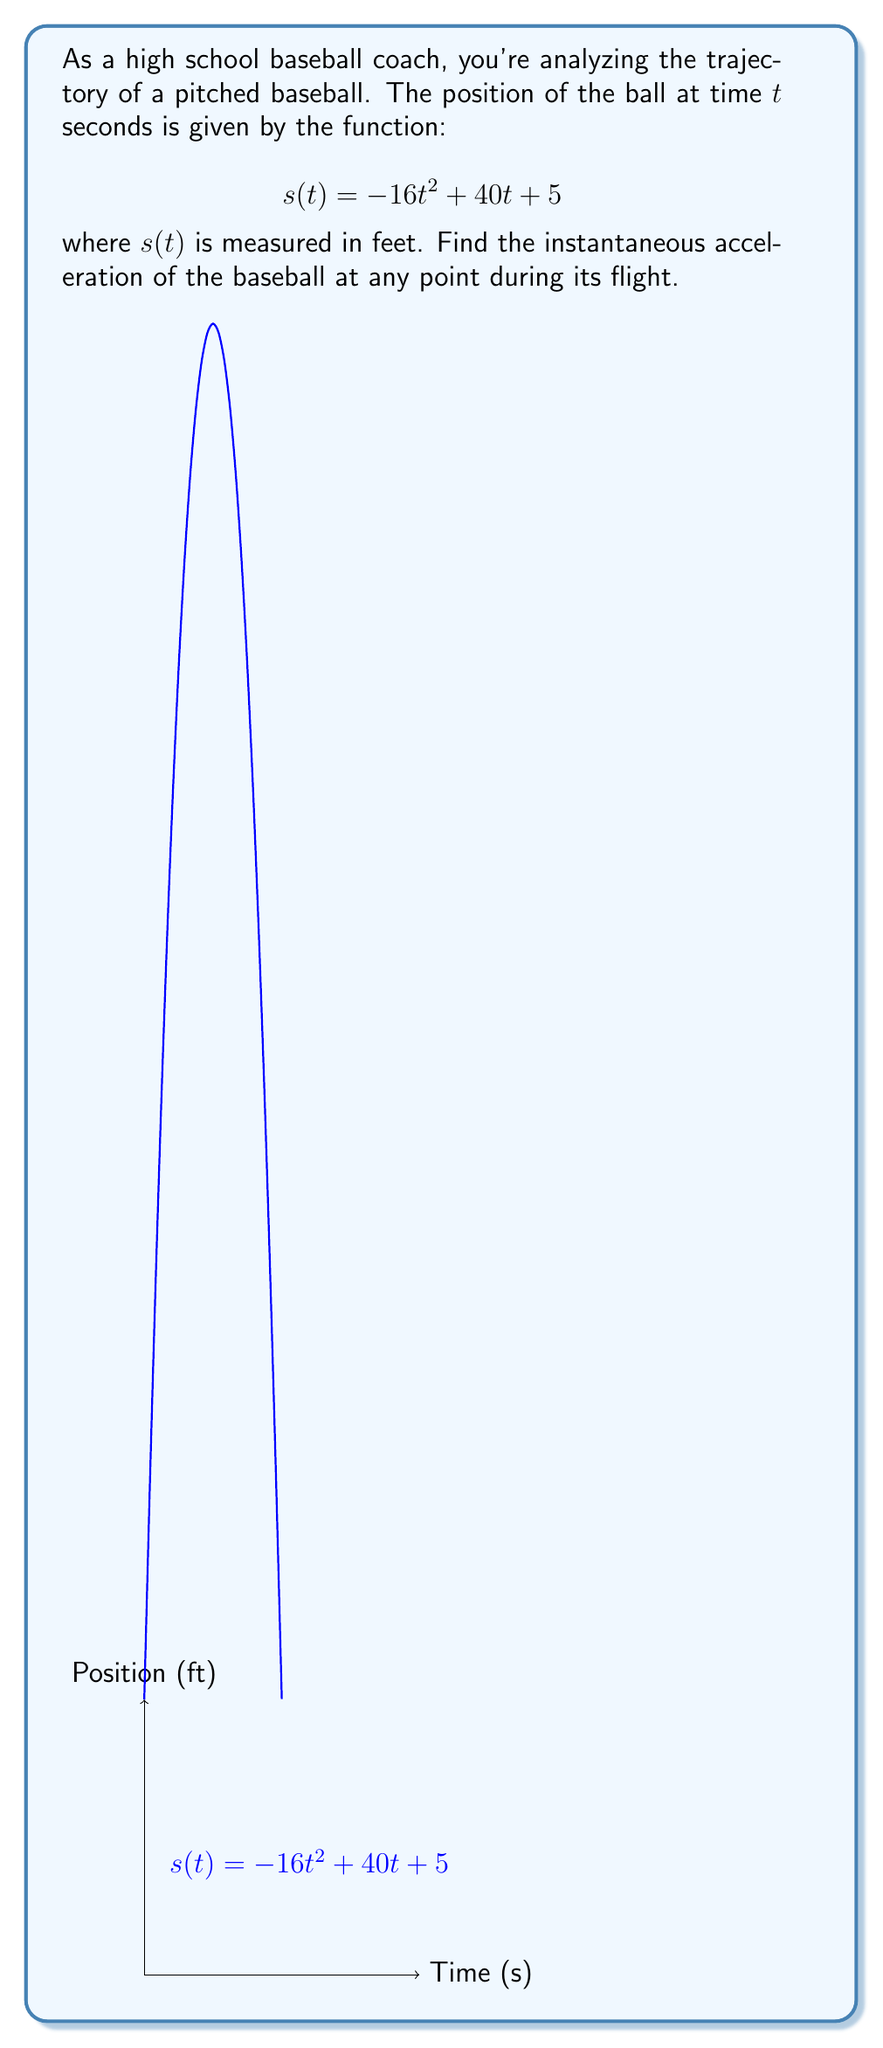Could you help me with this problem? To find the instantaneous acceleration, we need to take the second derivative of the position function. Let's go through this step-by-step:

1) We start with the position function: 
   $$s(t) = -16t^2 + 40t + 5$$

2) To find velocity, we take the first derivative:
   $$v(t) = s'(t) = -32t + 40$$

3) To find acceleration, we take the derivative of velocity (second derivative of position):
   $$a(t) = v'(t) = s''(t) = -32$$

4) We see that the acceleration is constant and doesn't depend on $t$. This makes sense because the only force acting on the baseball after it's pitched is gravity, which provides a constant acceleration of approximately 32 ft/s² downward.

5) The negative sign indicates that the acceleration is downward, opposing the upward direction we've defined as positive.
Answer: $a(t) = -32$ ft/s² 